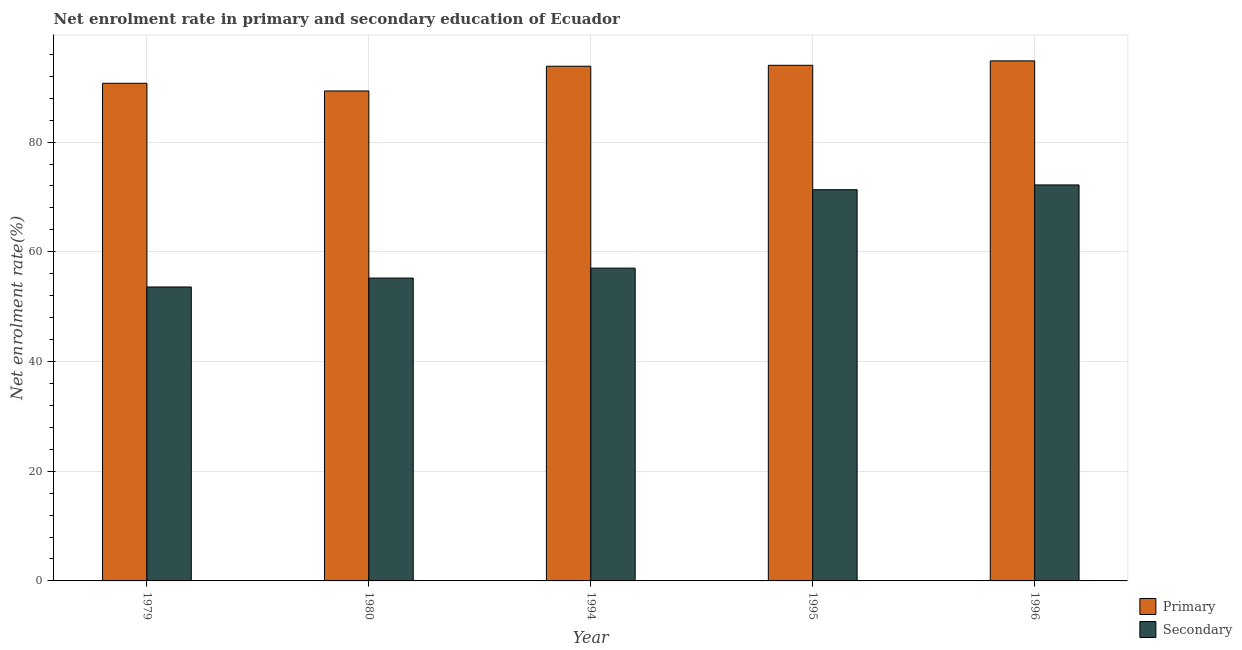How many different coloured bars are there?
Keep it short and to the point. 2. How many bars are there on the 1st tick from the right?
Your response must be concise. 2. What is the label of the 1st group of bars from the left?
Keep it short and to the point. 1979. What is the enrollment rate in secondary education in 1996?
Provide a succinct answer. 72.18. Across all years, what is the maximum enrollment rate in secondary education?
Keep it short and to the point. 72.18. Across all years, what is the minimum enrollment rate in primary education?
Make the answer very short. 89.32. In which year was the enrollment rate in secondary education maximum?
Make the answer very short. 1996. In which year was the enrollment rate in secondary education minimum?
Ensure brevity in your answer.  1979. What is the total enrollment rate in primary education in the graph?
Your response must be concise. 462.64. What is the difference between the enrollment rate in primary education in 1979 and that in 1995?
Keep it short and to the point. -3.27. What is the difference between the enrollment rate in primary education in 1994 and the enrollment rate in secondary education in 1980?
Give a very brief answer. 4.5. What is the average enrollment rate in primary education per year?
Your answer should be very brief. 92.53. What is the ratio of the enrollment rate in primary education in 1979 to that in 1994?
Offer a terse response. 0.97. Is the difference between the enrollment rate in secondary education in 1979 and 1996 greater than the difference between the enrollment rate in primary education in 1979 and 1996?
Ensure brevity in your answer.  No. What is the difference between the highest and the second highest enrollment rate in secondary education?
Ensure brevity in your answer.  0.87. What is the difference between the highest and the lowest enrollment rate in secondary education?
Keep it short and to the point. 18.6. In how many years, is the enrollment rate in secondary education greater than the average enrollment rate in secondary education taken over all years?
Offer a terse response. 2. What does the 2nd bar from the left in 1980 represents?
Ensure brevity in your answer.  Secondary. What does the 1st bar from the right in 1996 represents?
Offer a terse response. Secondary. How many bars are there?
Ensure brevity in your answer.  10. Are all the bars in the graph horizontal?
Ensure brevity in your answer.  No. Does the graph contain any zero values?
Make the answer very short. No. Does the graph contain grids?
Offer a terse response. Yes. What is the title of the graph?
Provide a short and direct response. Net enrolment rate in primary and secondary education of Ecuador. What is the label or title of the Y-axis?
Provide a succinct answer. Net enrolment rate(%). What is the Net enrolment rate(%) of Primary in 1979?
Provide a short and direct response. 90.72. What is the Net enrolment rate(%) of Secondary in 1979?
Your answer should be compact. 53.58. What is the Net enrolment rate(%) of Primary in 1980?
Keep it short and to the point. 89.32. What is the Net enrolment rate(%) in Secondary in 1980?
Your response must be concise. 55.21. What is the Net enrolment rate(%) in Primary in 1994?
Keep it short and to the point. 93.82. What is the Net enrolment rate(%) of Secondary in 1994?
Give a very brief answer. 57.02. What is the Net enrolment rate(%) in Primary in 1995?
Offer a very short reply. 93.99. What is the Net enrolment rate(%) of Secondary in 1995?
Keep it short and to the point. 71.31. What is the Net enrolment rate(%) in Primary in 1996?
Make the answer very short. 94.8. What is the Net enrolment rate(%) of Secondary in 1996?
Your answer should be very brief. 72.18. Across all years, what is the maximum Net enrolment rate(%) of Primary?
Offer a very short reply. 94.8. Across all years, what is the maximum Net enrolment rate(%) in Secondary?
Give a very brief answer. 72.18. Across all years, what is the minimum Net enrolment rate(%) of Primary?
Your answer should be very brief. 89.32. Across all years, what is the minimum Net enrolment rate(%) of Secondary?
Make the answer very short. 53.58. What is the total Net enrolment rate(%) in Primary in the graph?
Your response must be concise. 462.64. What is the total Net enrolment rate(%) of Secondary in the graph?
Keep it short and to the point. 309.3. What is the difference between the Net enrolment rate(%) of Primary in 1979 and that in 1980?
Your answer should be very brief. 1.4. What is the difference between the Net enrolment rate(%) of Secondary in 1979 and that in 1980?
Offer a terse response. -1.63. What is the difference between the Net enrolment rate(%) of Primary in 1979 and that in 1994?
Your answer should be very brief. -3.1. What is the difference between the Net enrolment rate(%) of Secondary in 1979 and that in 1994?
Provide a short and direct response. -3.43. What is the difference between the Net enrolment rate(%) of Primary in 1979 and that in 1995?
Your answer should be compact. -3.27. What is the difference between the Net enrolment rate(%) in Secondary in 1979 and that in 1995?
Provide a succinct answer. -17.73. What is the difference between the Net enrolment rate(%) of Primary in 1979 and that in 1996?
Make the answer very short. -4.08. What is the difference between the Net enrolment rate(%) in Secondary in 1979 and that in 1996?
Your answer should be very brief. -18.6. What is the difference between the Net enrolment rate(%) of Primary in 1980 and that in 1994?
Ensure brevity in your answer.  -4.5. What is the difference between the Net enrolment rate(%) in Secondary in 1980 and that in 1994?
Provide a succinct answer. -1.81. What is the difference between the Net enrolment rate(%) of Primary in 1980 and that in 1995?
Your answer should be very brief. -4.68. What is the difference between the Net enrolment rate(%) of Secondary in 1980 and that in 1995?
Ensure brevity in your answer.  -16.11. What is the difference between the Net enrolment rate(%) in Primary in 1980 and that in 1996?
Provide a short and direct response. -5.48. What is the difference between the Net enrolment rate(%) in Secondary in 1980 and that in 1996?
Give a very brief answer. -16.98. What is the difference between the Net enrolment rate(%) in Primary in 1994 and that in 1995?
Your answer should be compact. -0.17. What is the difference between the Net enrolment rate(%) in Secondary in 1994 and that in 1995?
Offer a very short reply. -14.3. What is the difference between the Net enrolment rate(%) of Primary in 1994 and that in 1996?
Your response must be concise. -0.98. What is the difference between the Net enrolment rate(%) in Secondary in 1994 and that in 1996?
Keep it short and to the point. -15.17. What is the difference between the Net enrolment rate(%) of Primary in 1995 and that in 1996?
Offer a terse response. -0.81. What is the difference between the Net enrolment rate(%) of Secondary in 1995 and that in 1996?
Ensure brevity in your answer.  -0.87. What is the difference between the Net enrolment rate(%) in Primary in 1979 and the Net enrolment rate(%) in Secondary in 1980?
Provide a succinct answer. 35.51. What is the difference between the Net enrolment rate(%) in Primary in 1979 and the Net enrolment rate(%) in Secondary in 1994?
Your answer should be compact. 33.7. What is the difference between the Net enrolment rate(%) of Primary in 1979 and the Net enrolment rate(%) of Secondary in 1995?
Provide a short and direct response. 19.4. What is the difference between the Net enrolment rate(%) of Primary in 1979 and the Net enrolment rate(%) of Secondary in 1996?
Give a very brief answer. 18.53. What is the difference between the Net enrolment rate(%) in Primary in 1980 and the Net enrolment rate(%) in Secondary in 1994?
Offer a very short reply. 32.3. What is the difference between the Net enrolment rate(%) in Primary in 1980 and the Net enrolment rate(%) in Secondary in 1995?
Give a very brief answer. 18. What is the difference between the Net enrolment rate(%) of Primary in 1980 and the Net enrolment rate(%) of Secondary in 1996?
Make the answer very short. 17.13. What is the difference between the Net enrolment rate(%) of Primary in 1994 and the Net enrolment rate(%) of Secondary in 1995?
Offer a terse response. 22.51. What is the difference between the Net enrolment rate(%) of Primary in 1994 and the Net enrolment rate(%) of Secondary in 1996?
Ensure brevity in your answer.  21.64. What is the difference between the Net enrolment rate(%) of Primary in 1995 and the Net enrolment rate(%) of Secondary in 1996?
Offer a terse response. 21.81. What is the average Net enrolment rate(%) of Primary per year?
Offer a very short reply. 92.53. What is the average Net enrolment rate(%) in Secondary per year?
Offer a terse response. 61.86. In the year 1979, what is the difference between the Net enrolment rate(%) in Primary and Net enrolment rate(%) in Secondary?
Keep it short and to the point. 37.13. In the year 1980, what is the difference between the Net enrolment rate(%) of Primary and Net enrolment rate(%) of Secondary?
Keep it short and to the point. 34.11. In the year 1994, what is the difference between the Net enrolment rate(%) of Primary and Net enrolment rate(%) of Secondary?
Provide a short and direct response. 36.8. In the year 1995, what is the difference between the Net enrolment rate(%) of Primary and Net enrolment rate(%) of Secondary?
Offer a very short reply. 22.68. In the year 1996, what is the difference between the Net enrolment rate(%) in Primary and Net enrolment rate(%) in Secondary?
Make the answer very short. 22.61. What is the ratio of the Net enrolment rate(%) of Primary in 1979 to that in 1980?
Offer a very short reply. 1.02. What is the ratio of the Net enrolment rate(%) of Secondary in 1979 to that in 1980?
Keep it short and to the point. 0.97. What is the ratio of the Net enrolment rate(%) in Primary in 1979 to that in 1994?
Make the answer very short. 0.97. What is the ratio of the Net enrolment rate(%) of Secondary in 1979 to that in 1994?
Your response must be concise. 0.94. What is the ratio of the Net enrolment rate(%) in Primary in 1979 to that in 1995?
Provide a short and direct response. 0.97. What is the ratio of the Net enrolment rate(%) of Secondary in 1979 to that in 1995?
Ensure brevity in your answer.  0.75. What is the ratio of the Net enrolment rate(%) of Primary in 1979 to that in 1996?
Keep it short and to the point. 0.96. What is the ratio of the Net enrolment rate(%) in Secondary in 1979 to that in 1996?
Your answer should be very brief. 0.74. What is the ratio of the Net enrolment rate(%) in Secondary in 1980 to that in 1994?
Your answer should be compact. 0.97. What is the ratio of the Net enrolment rate(%) in Primary in 1980 to that in 1995?
Offer a terse response. 0.95. What is the ratio of the Net enrolment rate(%) of Secondary in 1980 to that in 1995?
Offer a terse response. 0.77. What is the ratio of the Net enrolment rate(%) in Primary in 1980 to that in 1996?
Give a very brief answer. 0.94. What is the ratio of the Net enrolment rate(%) in Secondary in 1980 to that in 1996?
Your answer should be compact. 0.76. What is the ratio of the Net enrolment rate(%) of Secondary in 1994 to that in 1995?
Give a very brief answer. 0.8. What is the ratio of the Net enrolment rate(%) of Primary in 1994 to that in 1996?
Your response must be concise. 0.99. What is the ratio of the Net enrolment rate(%) of Secondary in 1994 to that in 1996?
Your response must be concise. 0.79. What is the ratio of the Net enrolment rate(%) in Secondary in 1995 to that in 1996?
Provide a short and direct response. 0.99. What is the difference between the highest and the second highest Net enrolment rate(%) in Primary?
Offer a very short reply. 0.81. What is the difference between the highest and the second highest Net enrolment rate(%) in Secondary?
Provide a succinct answer. 0.87. What is the difference between the highest and the lowest Net enrolment rate(%) of Primary?
Offer a terse response. 5.48. What is the difference between the highest and the lowest Net enrolment rate(%) of Secondary?
Provide a succinct answer. 18.6. 